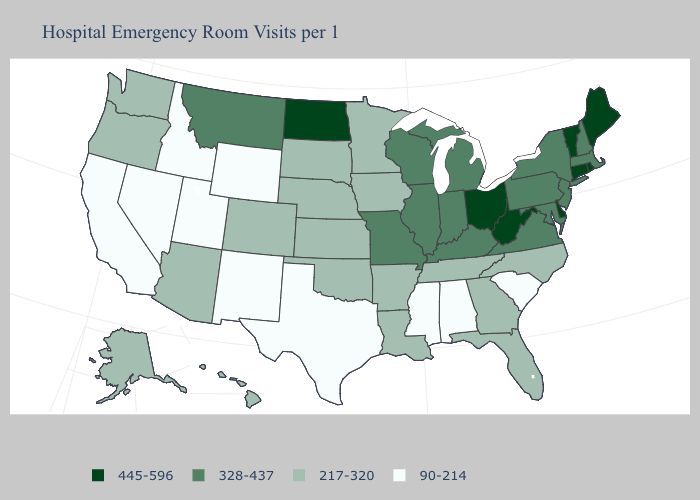Does the map have missing data?
Write a very short answer. No. Does the map have missing data?
Write a very short answer. No. Name the states that have a value in the range 328-437?
Write a very short answer. Illinois, Indiana, Kentucky, Maryland, Massachusetts, Michigan, Missouri, Montana, New Hampshire, New Jersey, New York, Pennsylvania, Virginia, Wisconsin. Does Michigan have the lowest value in the MidWest?
Keep it brief. No. Is the legend a continuous bar?
Give a very brief answer. No. Among the states that border Nebraska , which have the highest value?
Answer briefly. Missouri. Name the states that have a value in the range 217-320?
Concise answer only. Alaska, Arizona, Arkansas, Colorado, Florida, Georgia, Hawaii, Iowa, Kansas, Louisiana, Minnesota, Nebraska, North Carolina, Oklahoma, Oregon, South Dakota, Tennessee, Washington. Does New Mexico have the highest value in the USA?
Keep it brief. No. What is the value of Tennessee?
Answer briefly. 217-320. What is the lowest value in the South?
Concise answer only. 90-214. Name the states that have a value in the range 445-596?
Give a very brief answer. Connecticut, Delaware, Maine, North Dakota, Ohio, Rhode Island, Vermont, West Virginia. Does Wyoming have the lowest value in the USA?
Give a very brief answer. Yes. What is the value of Alaska?
Give a very brief answer. 217-320. What is the value of Wisconsin?
Be succinct. 328-437. Is the legend a continuous bar?
Give a very brief answer. No. 